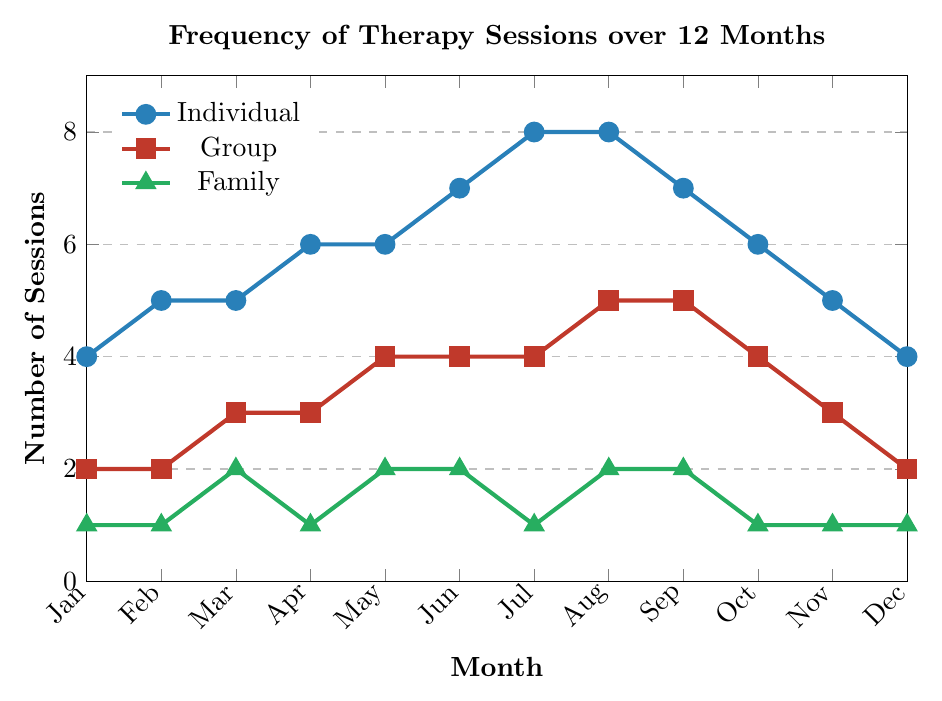What's the total number of Individual therapy sessions conducted over the entire 12 months? To find the total, sum up the values for Individual therapy sessions from January to December: 4 + 5 + 5 + 6 + 6 + 7 + 8 + 8 + 7 + 6 + 5 + 4 = 71
Answer: 71 Which therapy type saw the highest number of sessions in any single month? By examining the figure, the highest number of sessions occurs in August for Individual therapy with 8 sessions.
Answer: Individual During which month did Family therapy sessions have their peak, and what is the value? Family therapy sessions peaked in March, May, August, and September with 2 sessions each.
Answer: March, May, August, September (2 sessions each) What is the difference in the number of Group therapy sessions between January and August? Group therapy sessions in January were 2, and in August, they were 5. The difference is 5 - 2 = 3.
Answer: 3 How many more Individual therapy sessions were there compared to Group therapy sessions in July? In July, Individual therapy sessions were 8, and Group therapy sessions were 4. The difference is 8 - 4 = 4.
Answer: 4 What's the average number of Group therapy sessions per month across the whole year? Sum the number of Group therapy sessions from January to December: 2 + 2 + 3 + 3 + 4 + 4 + 4 + 5 + 5 + 4 + 3 + 2 = 41. Average = 41 / 12 ≈ 3.42
Answer: 3.42 Compare the trend of Individual and Family therapy sessions from June to August. What do you notice? From June to August, Individual sessions increased (7, 8, 8) while Family sessions varied (2, 1, and 2). Individual therapy steadily increased, whereas Family therapy showed no clear trend.
Answer: Individual had a consistent increase, Family was inconsistent In how many months did Group therapy sessions outnumber Family therapy sessions? By comparing monthly values, Group outnumbered Family in every month except March. Thus, it’s 11 months.
Answer: 11 What is the ratio of Individual to Family therapy sessions in December? In December, there were 4 Individual sessions and 1 Family session. The ratio is 4:1.
Answer: 4:1 